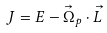Convert formula to latex. <formula><loc_0><loc_0><loc_500><loc_500>J = E - { \vec { \Omega } } _ { p } \cdot { \vec { L } }</formula> 